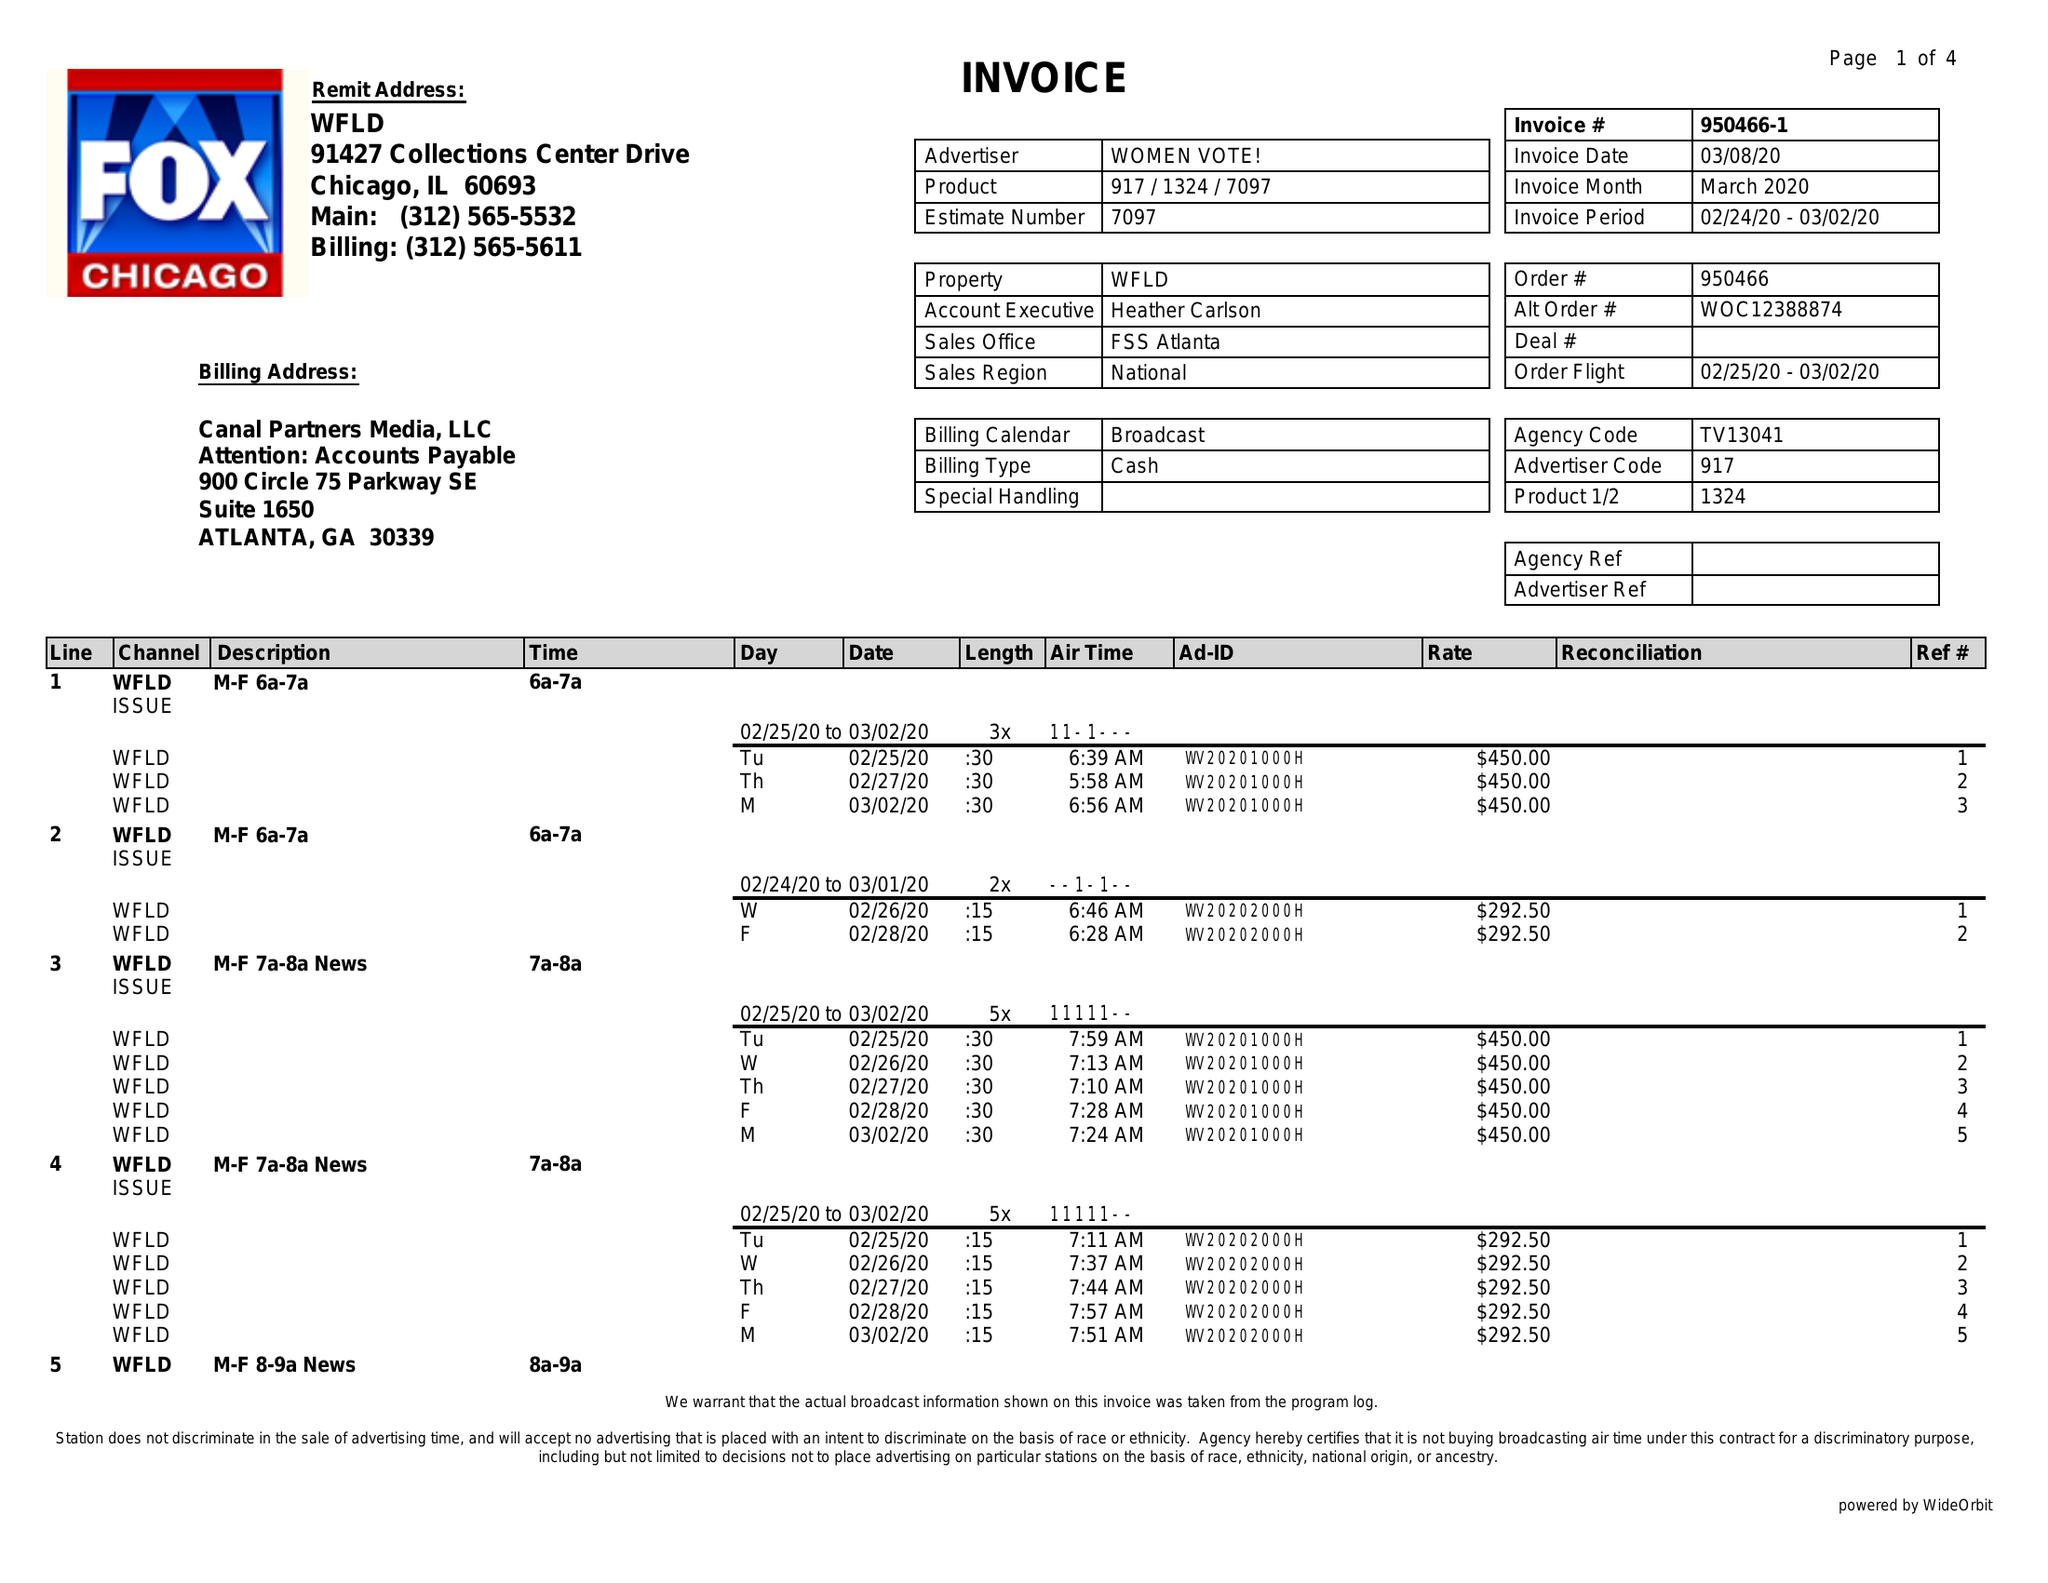What is the value for the contract_num?
Answer the question using a single word or phrase. 950466 